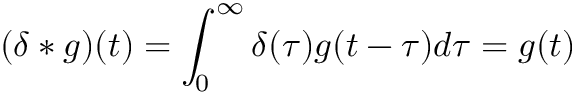<formula> <loc_0><loc_0><loc_500><loc_500>( \delta * g ) ( t ) = \int _ { 0 } ^ { \infty } \delta ( \tau ) g ( t - \tau ) d \tau = g ( t )</formula> 